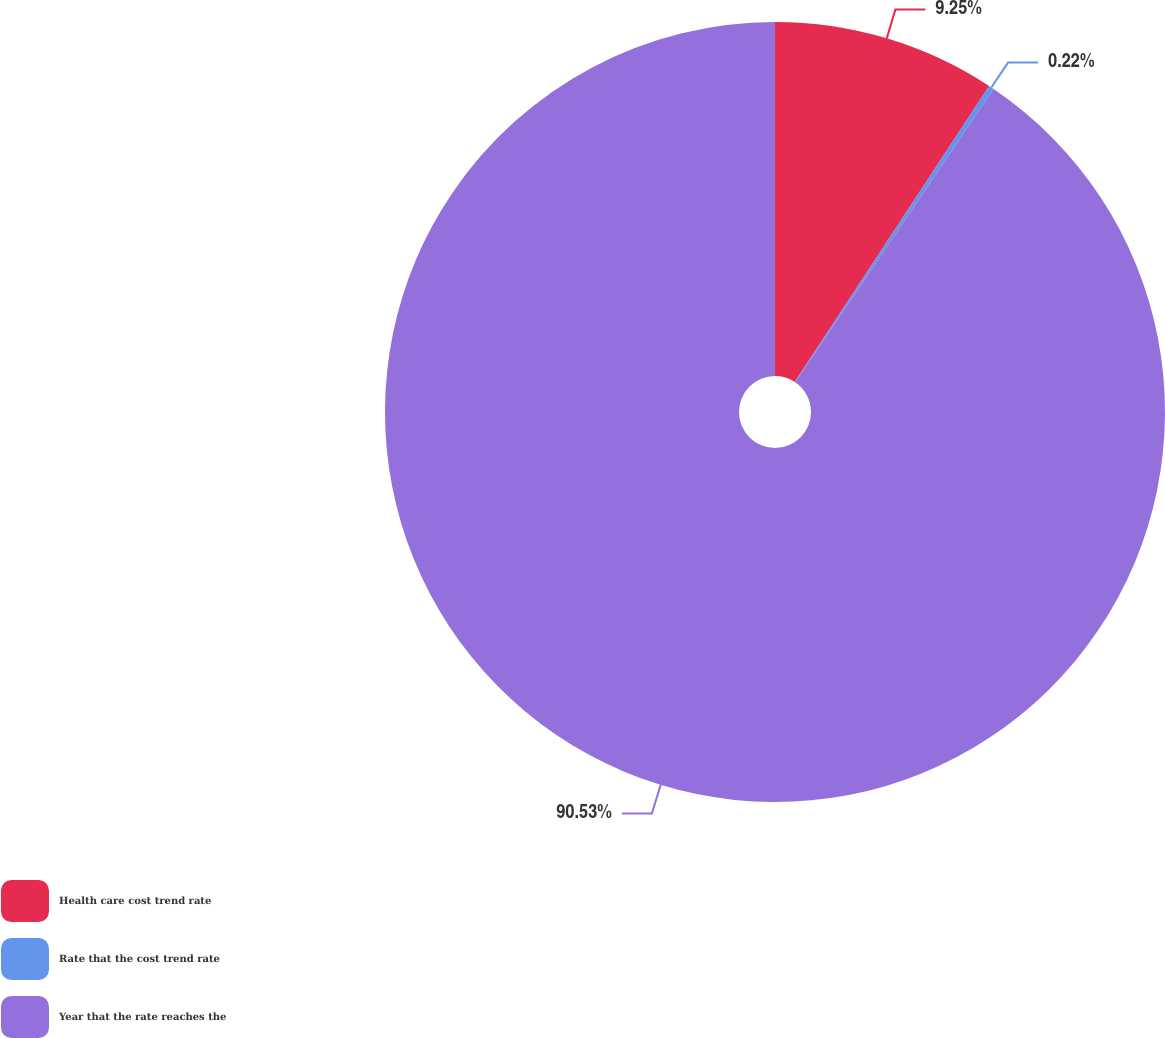Convert chart to OTSL. <chart><loc_0><loc_0><loc_500><loc_500><pie_chart><fcel>Health care cost trend rate<fcel>Rate that the cost trend rate<fcel>Year that the rate reaches the<nl><fcel>9.25%<fcel>0.22%<fcel>90.52%<nl></chart> 